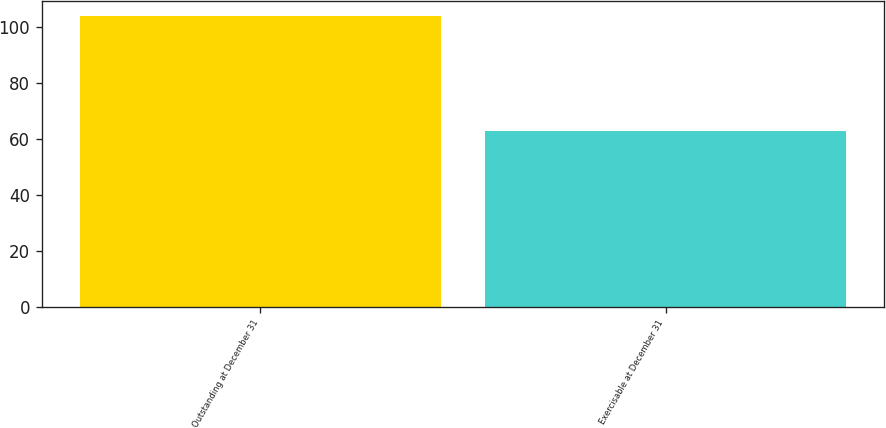<chart> <loc_0><loc_0><loc_500><loc_500><bar_chart><fcel>Outstanding at December 31<fcel>Exercisable at December 31<nl><fcel>104<fcel>63<nl></chart> 